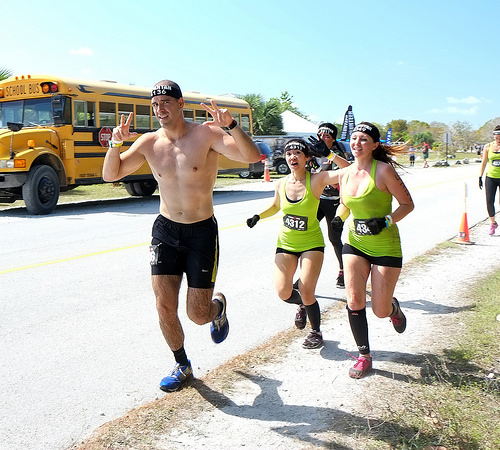<image>
Can you confirm if the bus is on the runner? No. The bus is not positioned on the runner. They may be near each other, but the bus is not supported by or resting on top of the runner. Is there a woman one in front of the woman two? No. The woman one is not in front of the woman two. The spatial positioning shows a different relationship between these objects. 